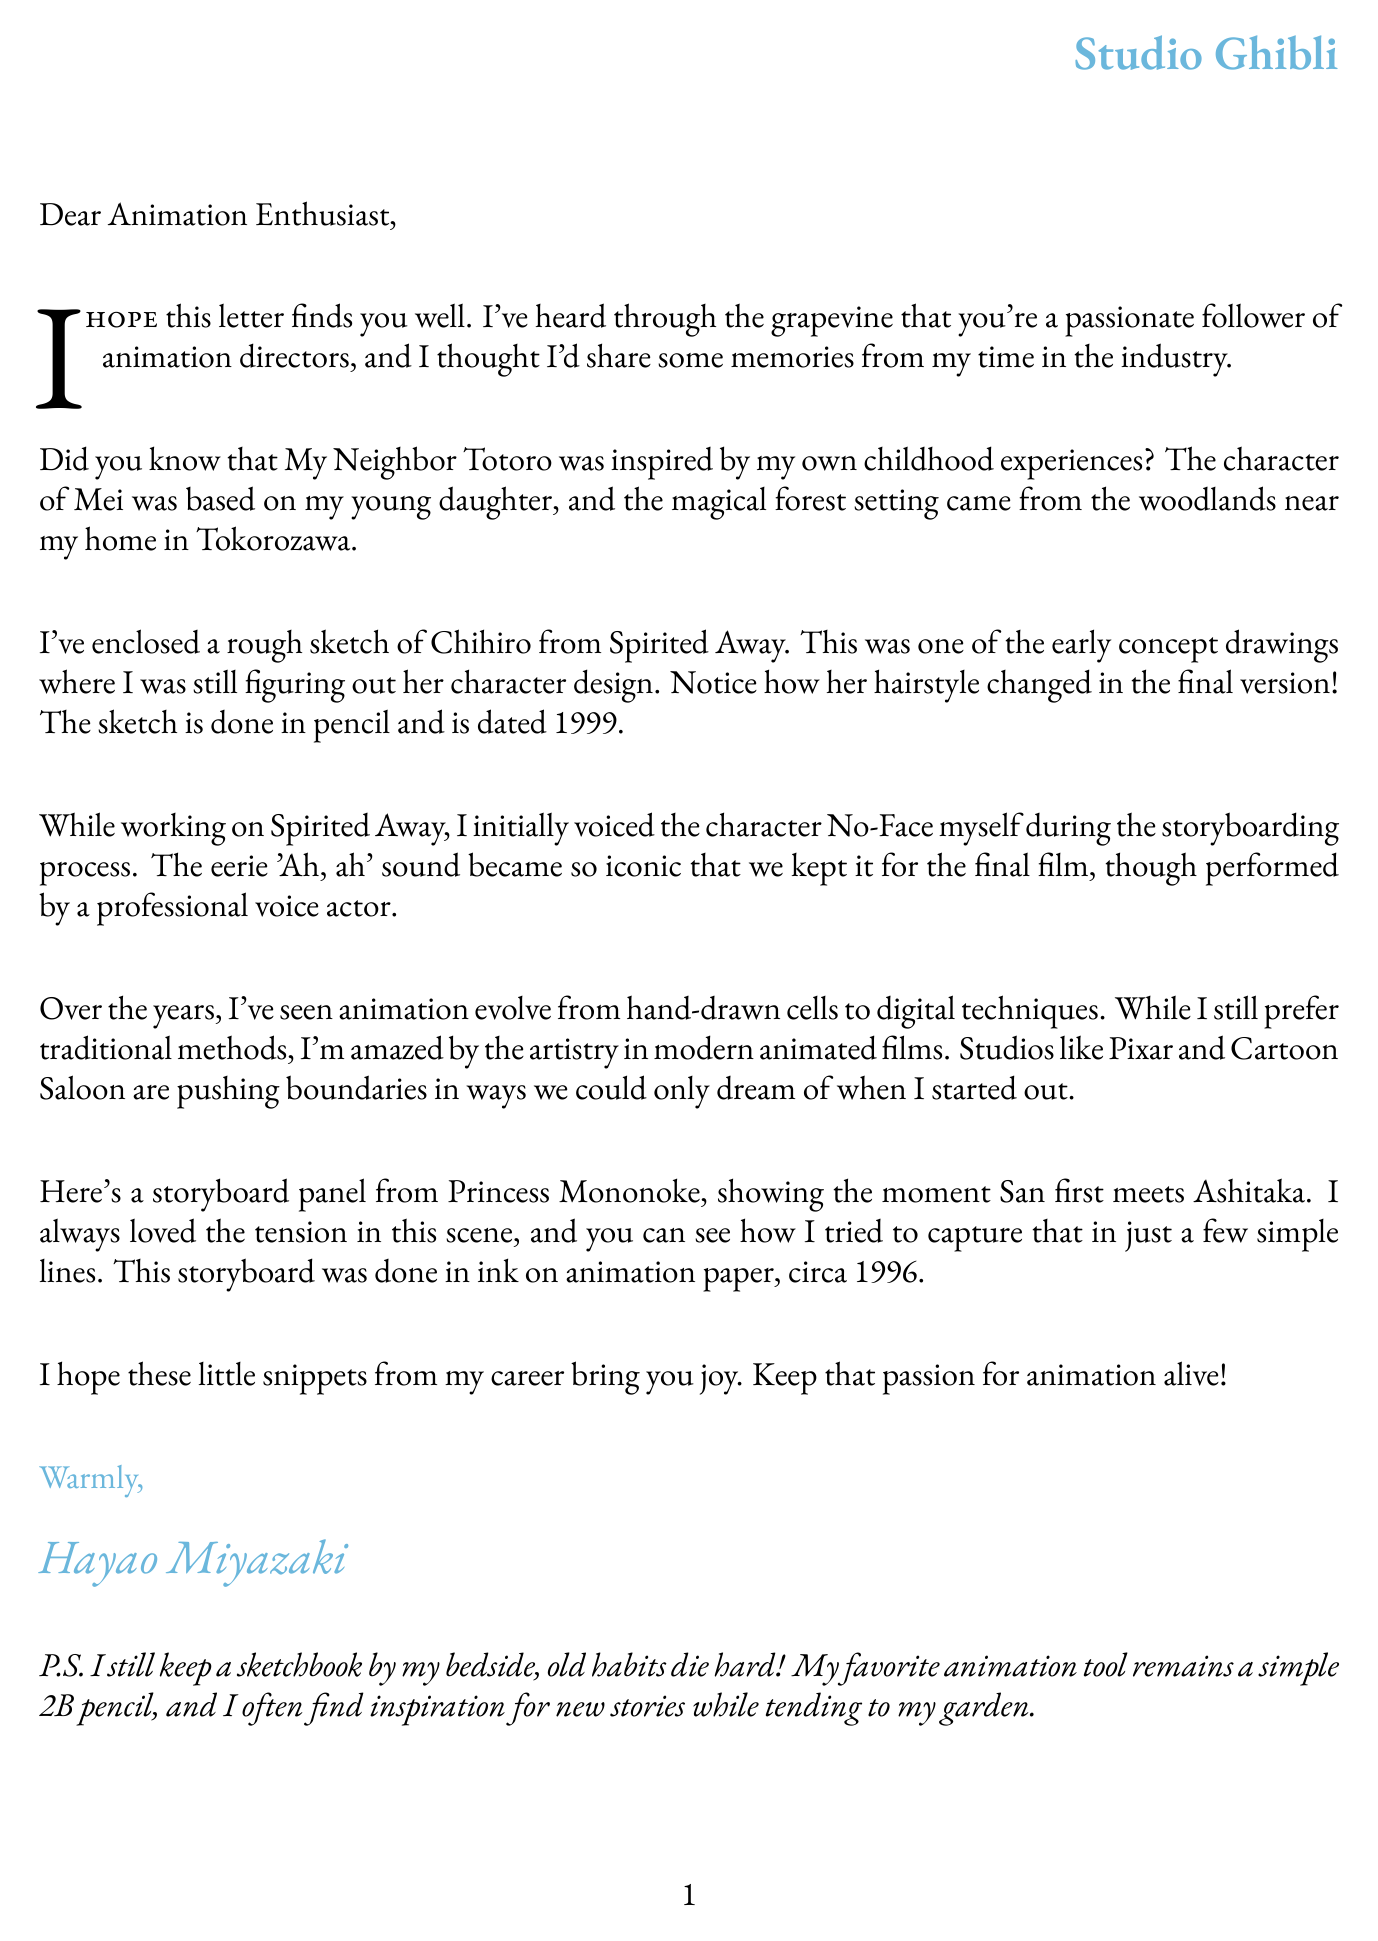What is the name of the director who wrote the letter? The letter is signed by Hayao Miyazaki, the retired animation director.
Answer: Hayao Miyazaki Which studio is associated with the director? The director is linked to Studio Ghibli, as mentioned in the header of the letter.
Answer: Studio Ghibli What character inspired the creation of Mei in My Neighbor Totoro? The anecdote reveals that Mei was inspired by the director's young daughter.
Answer: Young daughter What year is the sketch of Chihiro from Spirited Away dated? The letter specifies that the sketch is dated 1999.
Answer: 1999 What technique does the director prefer for animation? The director mentions a preference for traditional methods over digital ones in the document.
Answer: Traditional methods What character did the director originally voice in Spirited Away? The letter states that the director initially voiced the character No-Face during storyboarding.
Answer: No-Face What type of art medium was used for the storyboard panel from Princess Mononoke? The document describes the storyboard panel as being done in ink on animation paper.
Answer: Ink on animation paper In what year was the storyboard for Princess Mononoke created? The documentation indicates that the storyboard is from circa 1996.
Answer: 1996 What personal item does the director keep by their bedside? The director mentions keeping a sketchbook by their bedside in the postscript.
Answer: Sketchbook 